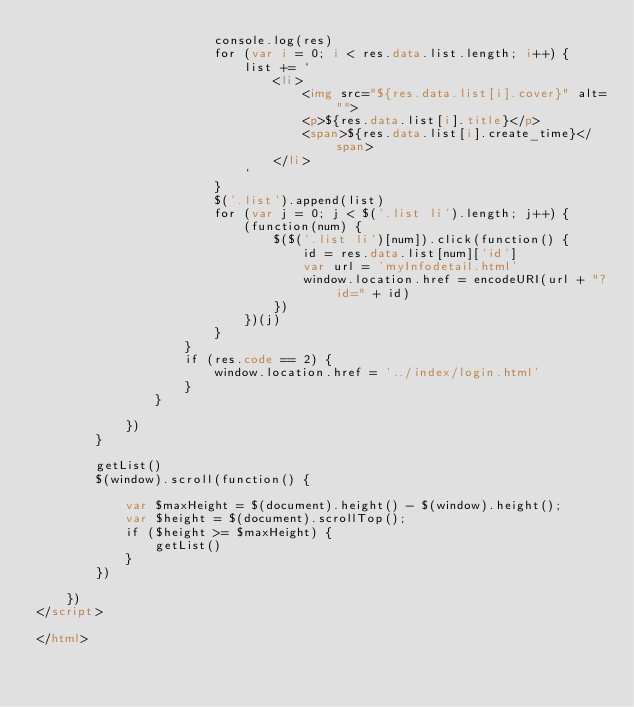Convert code to text. <code><loc_0><loc_0><loc_500><loc_500><_HTML_>                        console.log(res)
                        for (var i = 0; i < res.data.list.length; i++) {
                            list += `
                                <li>
                                    <img src="${res.data.list[i].cover}" alt="">
                                    <p>${res.data.list[i].title}</p>
                                    <span>${res.data.list[i].create_time}</span>
                                </li>
                            `
                        }
                        $('.list').append(list)
                        for (var j = 0; j < $('.list li').length; j++) {
                            (function(num) {
                                $($('.list li')[num]).click(function() {
                                    id = res.data.list[num]['id']
                                    var url = 'myInfodetail.html'
                                    window.location.href = encodeURI(url + "?id=" + id)
                                })
                            })(j)
                        }
                    }
                    if (res.code == 2) {
                        window.location.href = '../index/login.html'
                    }
                }

            })
        }

        getList()
        $(window).scroll(function() {

            var $maxHeight = $(document).height() - $(window).height();
            var $height = $(document).scrollTop();
            if ($height >= $maxHeight) {
                getList()
            }
        })

    })
</script>

</html></code> 